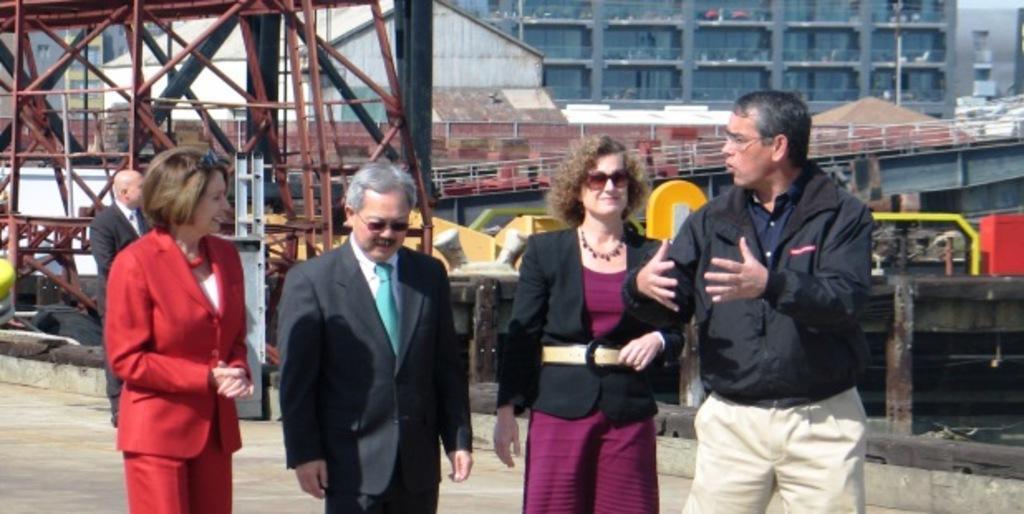Describe this image in one or two sentences. There are four persons standing and there is another person standing behind them and there is a building and few other objects in the background. 